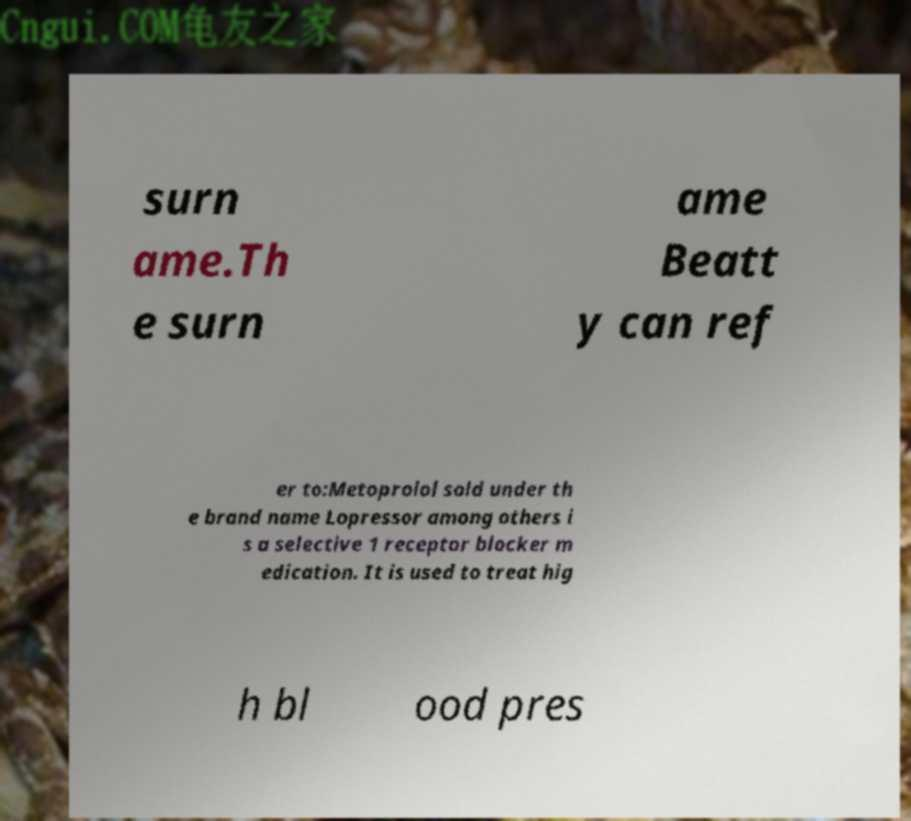There's text embedded in this image that I need extracted. Can you transcribe it verbatim? surn ame.Th e surn ame Beatt y can ref er to:Metoprolol sold under th e brand name Lopressor among others i s a selective 1 receptor blocker m edication. It is used to treat hig h bl ood pres 